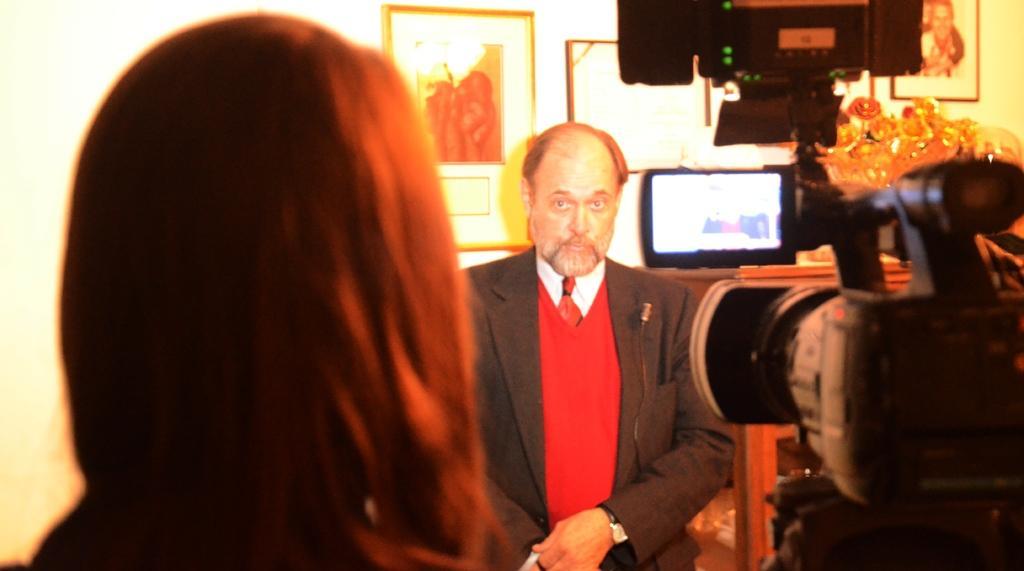Can you describe this image briefly? In this image there is a person and a camera , and at the background there is a person, frames attached to the wall, television and some objects on the cupboard. 